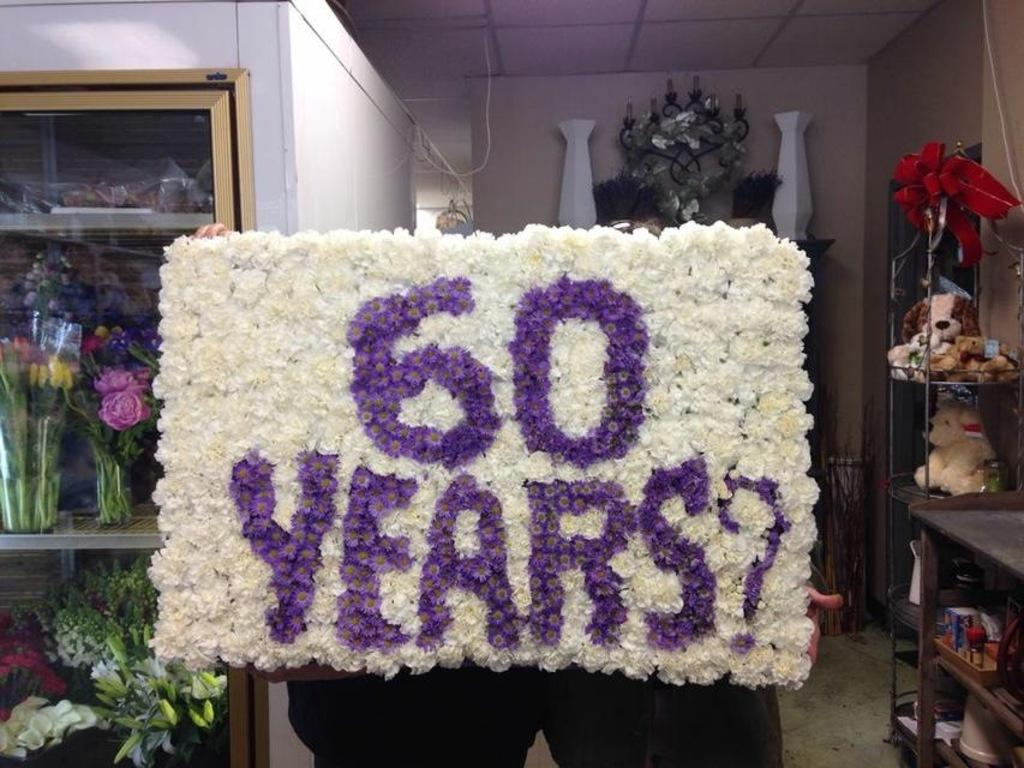<image>
Describe the image concisely. Sixtry years banner with flowers and vases near 